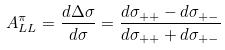<formula> <loc_0><loc_0><loc_500><loc_500>A _ { L L } ^ { \pi } = \frac { d \Delta \sigma } { d \sigma } = \frac { d \sigma _ { + + } - d \sigma _ { + - } } { d \sigma _ { + + } + d \sigma _ { + - } }</formula> 